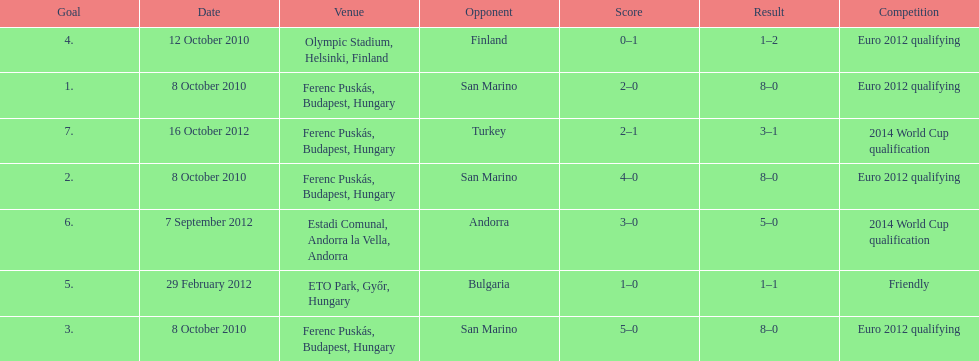In what year was szalai's first international goal? 2010. 